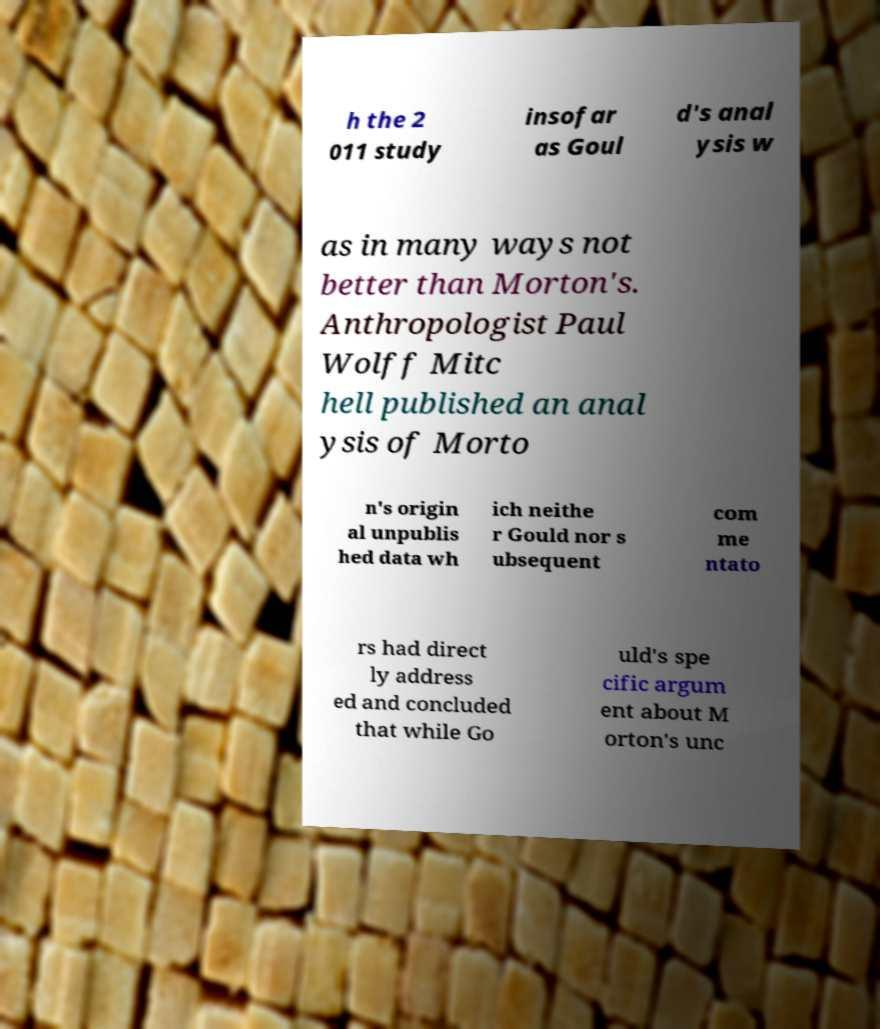Could you assist in decoding the text presented in this image and type it out clearly? h the 2 011 study insofar as Goul d's anal ysis w as in many ways not better than Morton's. Anthropologist Paul Wolff Mitc hell published an anal ysis of Morto n's origin al unpublis hed data wh ich neithe r Gould nor s ubsequent com me ntato rs had direct ly address ed and concluded that while Go uld's spe cific argum ent about M orton's unc 